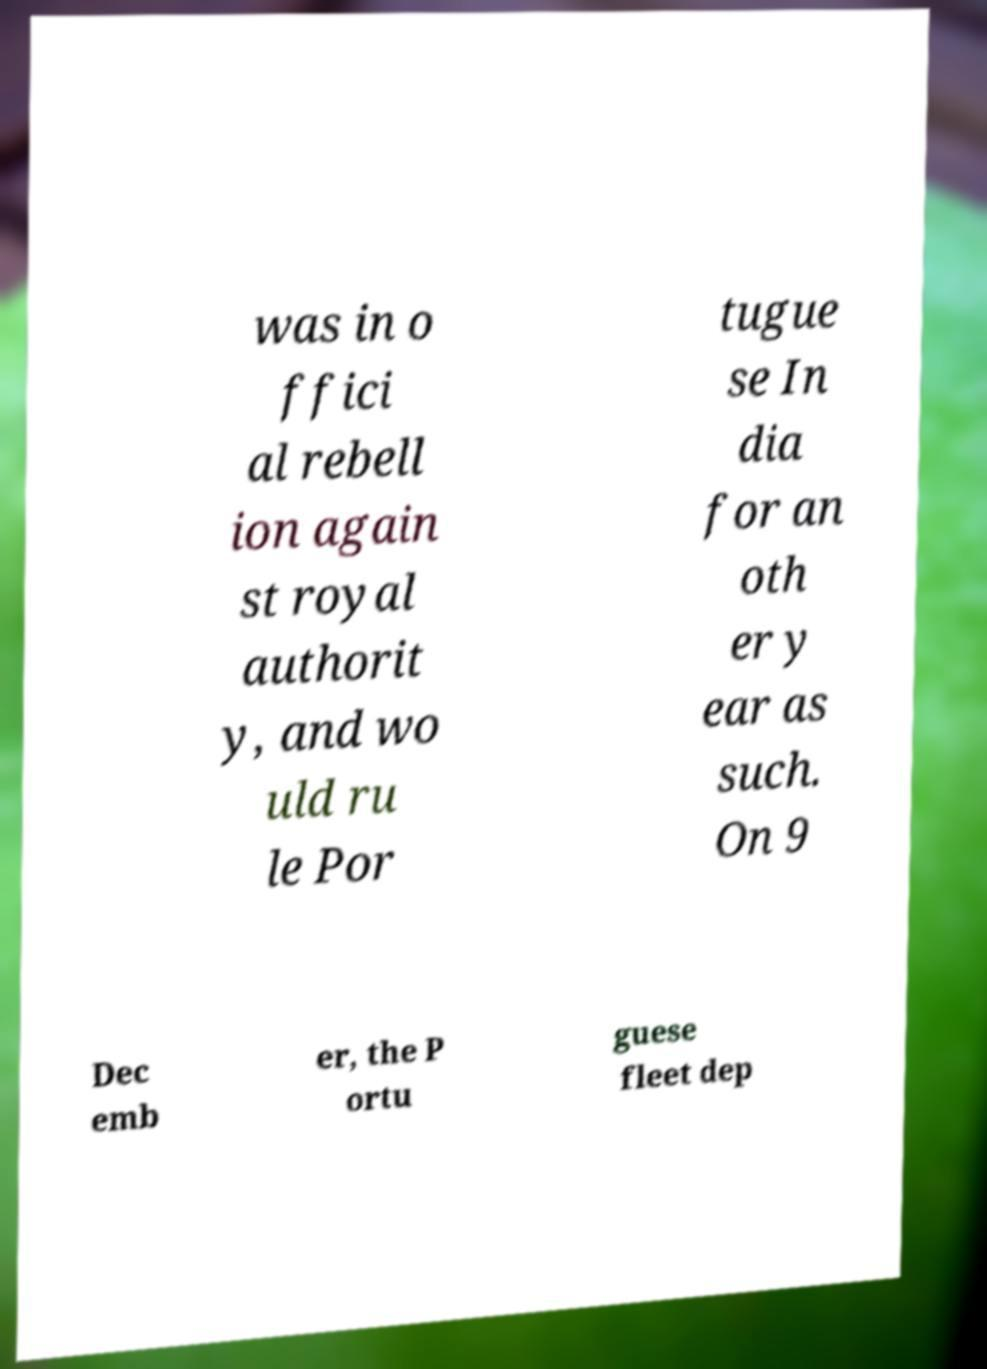I need the written content from this picture converted into text. Can you do that? was in o ffici al rebell ion again st royal authorit y, and wo uld ru le Por tugue se In dia for an oth er y ear as such. On 9 Dec emb er, the P ortu guese fleet dep 